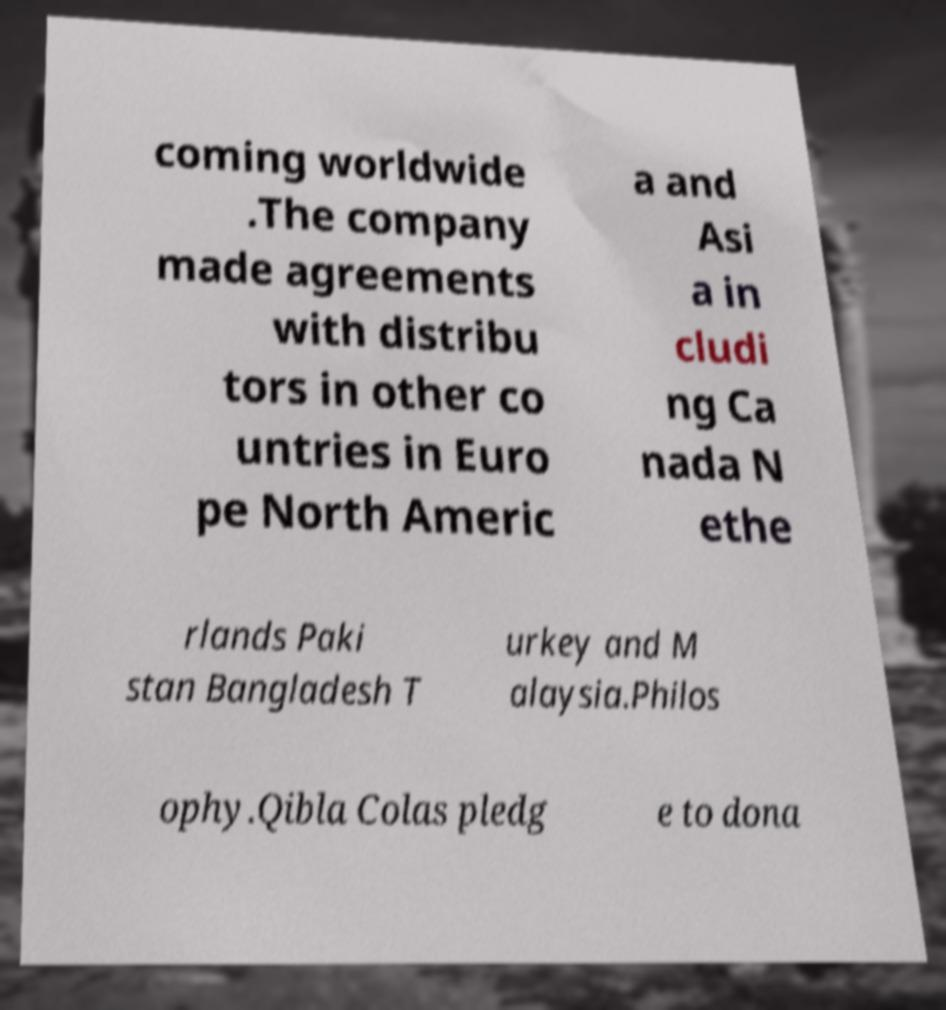Could you extract and type out the text from this image? coming worldwide .The company made agreements with distribu tors in other co untries in Euro pe North Americ a and Asi a in cludi ng Ca nada N ethe rlands Paki stan Bangladesh T urkey and M alaysia.Philos ophy.Qibla Colas pledg e to dona 